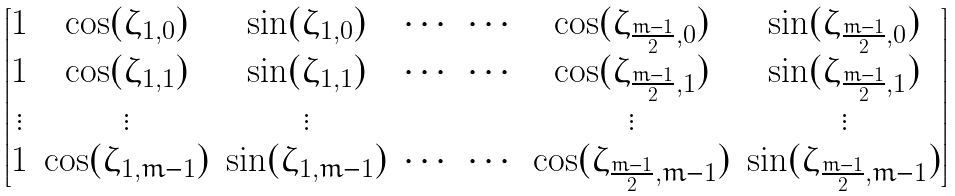Convert formula to latex. <formula><loc_0><loc_0><loc_500><loc_500>\begin{bmatrix} 1 & \cos ( \zeta _ { 1 , 0 } ) & \sin ( \zeta _ { 1 , 0 } ) & \cdots & \cdots & \cos ( \zeta _ { \frac { m - 1 } { 2 } , 0 } ) & \sin ( \zeta _ { \frac { m - 1 } { 2 } , 0 } ) \\ 1 & \cos ( \zeta _ { 1 , 1 } ) & \sin ( \zeta _ { 1 , 1 } ) & \cdots & \cdots & \cos ( \zeta _ { \frac { m - 1 } { 2 } , 1 } ) & \sin ( \zeta _ { \frac { m - 1 } { 2 } , 1 } ) \\ \vdots & \vdots & \vdots & & & \vdots & \vdots \\ 1 & \cos ( \zeta _ { 1 , m - 1 } ) & \sin ( \zeta _ { 1 , m - 1 } ) & \cdots & \cdots & \cos ( \zeta _ { \frac { m - 1 } { 2 } , m - 1 } ) & \sin ( \zeta _ { \frac { m - 1 } { 2 } , m - 1 } ) \end{bmatrix}</formula> 